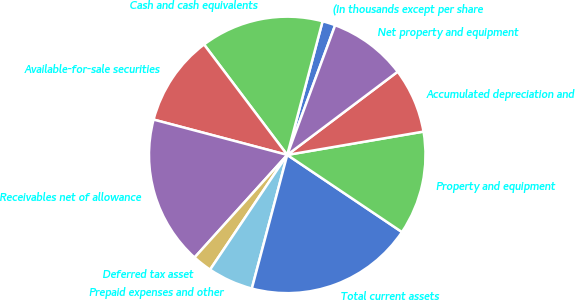<chart> <loc_0><loc_0><loc_500><loc_500><pie_chart><fcel>(In thousands except per share<fcel>Cash and cash equivalents<fcel>Available-for-sale securities<fcel>Receivables net of allowance<fcel>Deferred tax asset<fcel>Prepaid expenses and other<fcel>Total current assets<fcel>Property and equipment<fcel>Accumulated depreciation and<fcel>Net property and equipment<nl><fcel>1.52%<fcel>14.39%<fcel>10.61%<fcel>17.42%<fcel>2.27%<fcel>5.3%<fcel>19.7%<fcel>12.12%<fcel>7.58%<fcel>9.09%<nl></chart> 